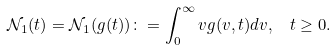Convert formula to latex. <formula><loc_0><loc_0><loc_500><loc_500>\mathcal { N } _ { 1 } ( t ) = \mathcal { N } _ { 1 } ( g ( t ) ) \colon = \int _ { 0 } ^ { \infty } v g ( v , t ) d v , \ \ t \geq 0 .</formula> 